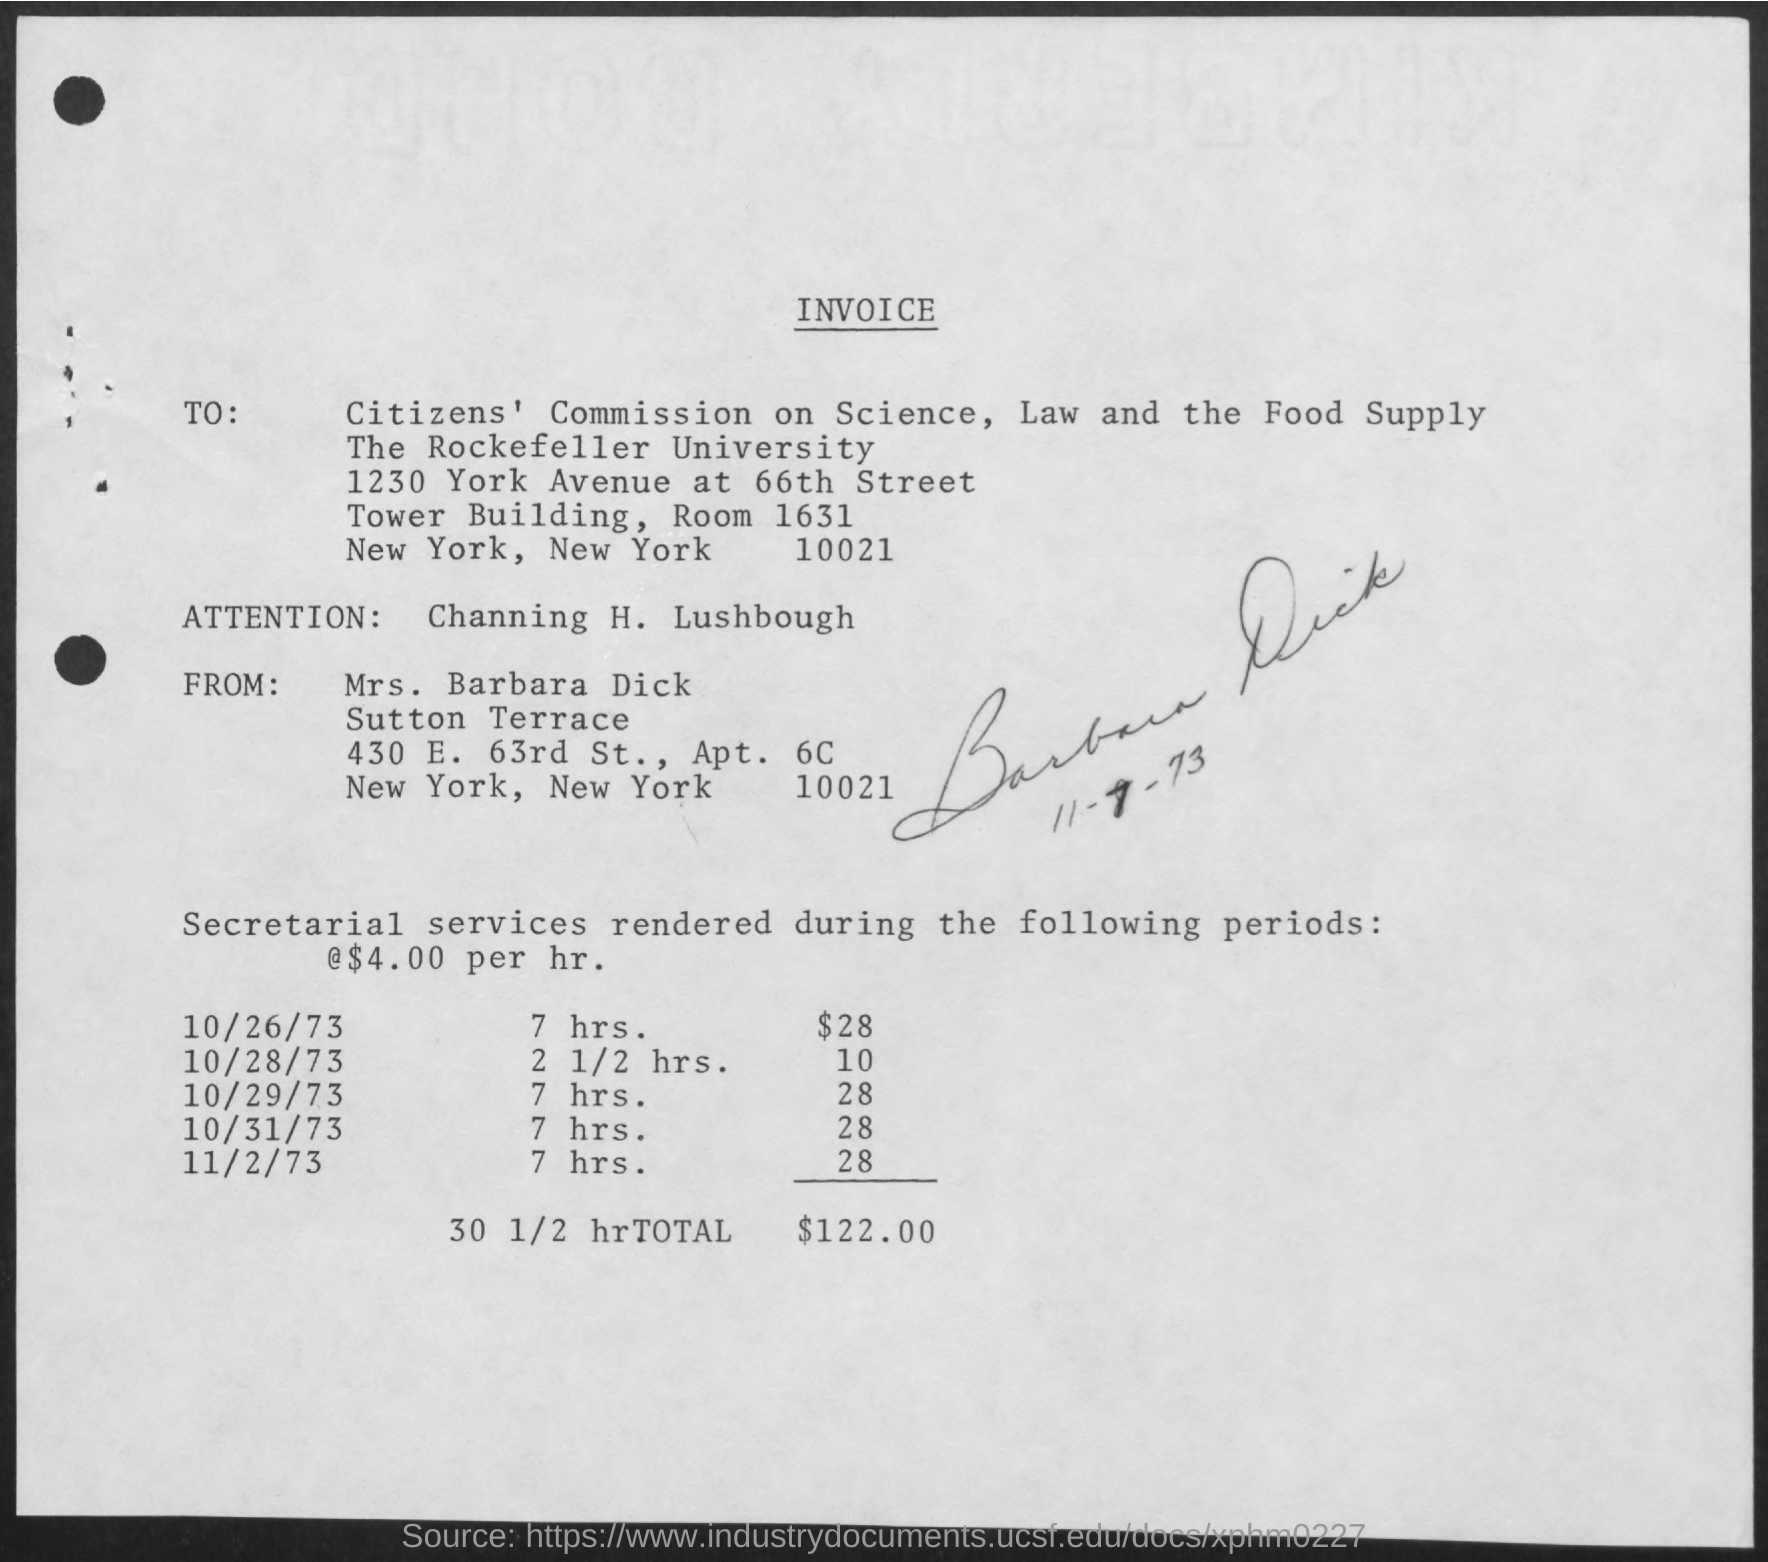Who is raising the invoice?
Make the answer very short. Mrs. Barbara Dick. On which date is the lowest secretarial service rendered?
Make the answer very short. 10/28/73. What is the total secreterial service amount rendered during the period?
Give a very brief answer. $122.00. What is the total hours given in the invoice?
Offer a terse response. 30 1/2 hr. 